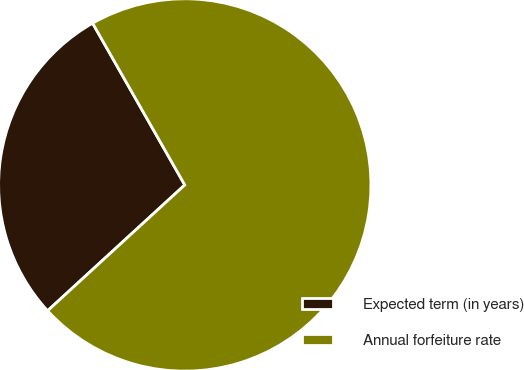<chart> <loc_0><loc_0><loc_500><loc_500><pie_chart><fcel>Expected term (in years)<fcel>Annual forfeiture rate<nl><fcel>28.57%<fcel>71.43%<nl></chart> 